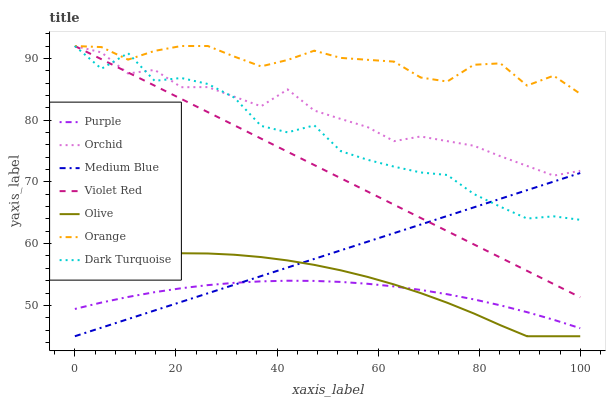Does Purple have the minimum area under the curve?
Answer yes or no. Yes. Does Orange have the maximum area under the curve?
Answer yes or no. Yes. Does Dark Turquoise have the minimum area under the curve?
Answer yes or no. No. Does Dark Turquoise have the maximum area under the curve?
Answer yes or no. No. Is Medium Blue the smoothest?
Answer yes or no. Yes. Is Dark Turquoise the roughest?
Answer yes or no. Yes. Is Purple the smoothest?
Answer yes or no. No. Is Purple the roughest?
Answer yes or no. No. Does Purple have the lowest value?
Answer yes or no. No. Does Purple have the highest value?
Answer yes or no. No. Is Purple less than Orchid?
Answer yes or no. Yes. Is Orange greater than Olive?
Answer yes or no. Yes. Does Purple intersect Orchid?
Answer yes or no. No. 